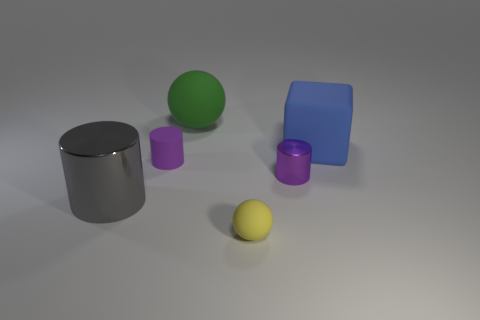What number of things are either blue matte cubes behind the small purple metallic cylinder or purple cylinders that are in front of the purple matte cylinder?
Provide a short and direct response. 2. Is there any other thing that is the same shape as the blue matte object?
Your answer should be compact. No. How many tiny brown rubber cylinders are there?
Your answer should be very brief. 0. Are there any blocks that have the same size as the purple metal object?
Provide a succinct answer. No. Do the large sphere and the thing in front of the gray metal cylinder have the same material?
Give a very brief answer. Yes. What is the material of the tiny cylinder in front of the rubber cylinder?
Provide a short and direct response. Metal. What size is the yellow ball?
Keep it short and to the point. Small. There is a purple thing right of the green thing; is its size the same as the rubber thing that is behind the blue matte thing?
Offer a very short reply. No. What is the size of the other purple object that is the same shape as the tiny metal thing?
Provide a succinct answer. Small. There is a blue thing; is its size the same as the ball that is behind the small metallic cylinder?
Give a very brief answer. Yes. 